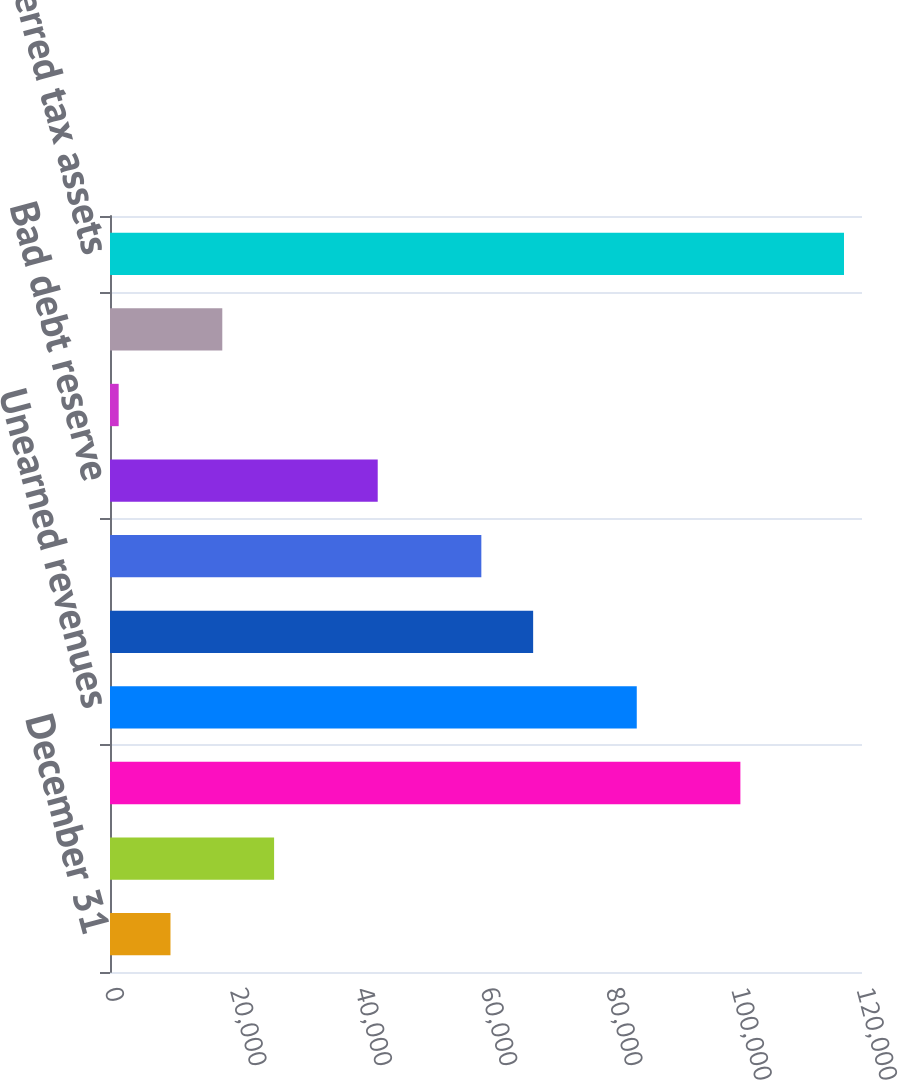Convert chart. <chart><loc_0><loc_0><loc_500><loc_500><bar_chart><fcel>December 31<fcel>Termite accrual<fcel>Insurance and contingencies<fcel>Unearned revenues<fcel>Compensation and benefits<fcel>State and foreign operating<fcel>Bad debt reserve<fcel>Other<fcel>Valuation allowance<fcel>Total deferred tax assets<nl><fcel>9651.4<fcel>26186.2<fcel>100593<fcel>84058<fcel>67523.2<fcel>59255.8<fcel>42721<fcel>1384<fcel>17918.8<fcel>117128<nl></chart> 